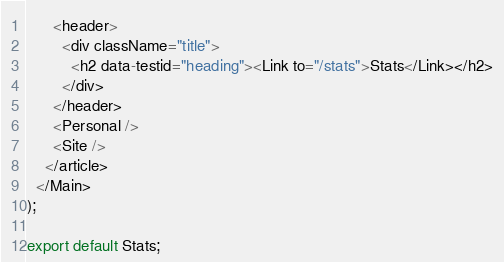<code> <loc_0><loc_0><loc_500><loc_500><_JavaScript_>      <header>
        <div className="title">
          <h2 data-testid="heading"><Link to="/stats">Stats</Link></h2>
        </div>
      </header>
      <Personal />
      <Site />
    </article>
  </Main>
);

export default Stats;
</code> 